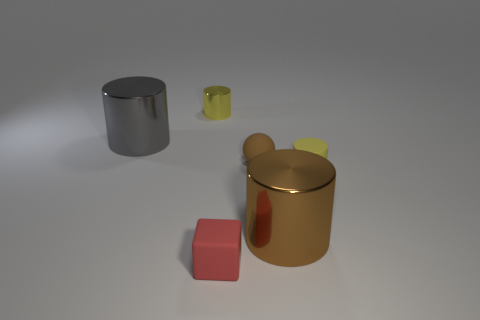Subtract all large brown cylinders. How many cylinders are left? 3 Subtract all gray cylinders. How many cylinders are left? 3 Subtract all blue balls. How many yellow cylinders are left? 2 Add 2 big yellow spheres. How many objects exist? 8 Subtract all cylinders. How many objects are left? 2 Subtract 3 cylinders. How many cylinders are left? 1 Subtract 0 blue spheres. How many objects are left? 6 Subtract all green spheres. Subtract all green cylinders. How many spheres are left? 1 Subtract all large cyan rubber cylinders. Subtract all large things. How many objects are left? 4 Add 1 matte blocks. How many matte blocks are left? 2 